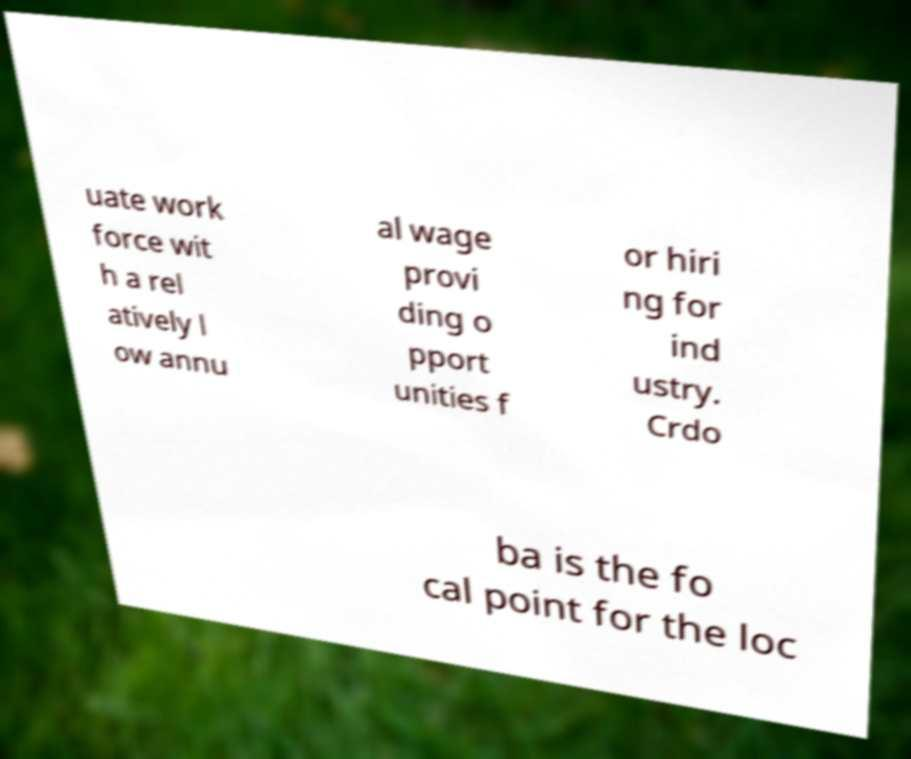What messages or text are displayed in this image? I need them in a readable, typed format. uate work force wit h a rel atively l ow annu al wage provi ding o pport unities f or hiri ng for ind ustry. Crdo ba is the fo cal point for the loc 